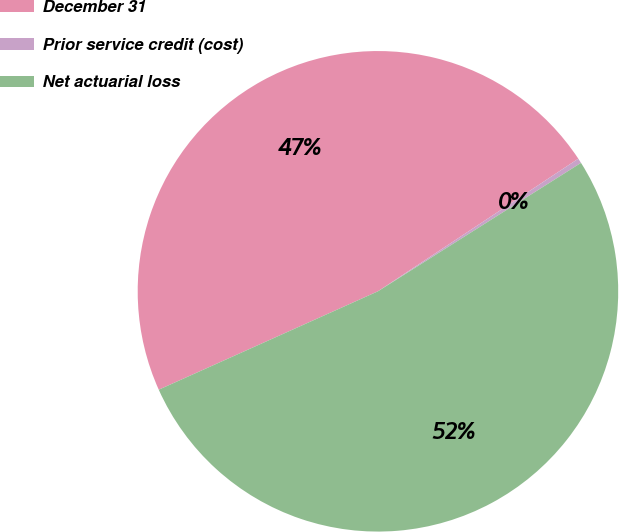Convert chart to OTSL. <chart><loc_0><loc_0><loc_500><loc_500><pie_chart><fcel>December 31<fcel>Prior service credit (cost)<fcel>Net actuarial loss<nl><fcel>47.41%<fcel>0.33%<fcel>52.26%<nl></chart> 